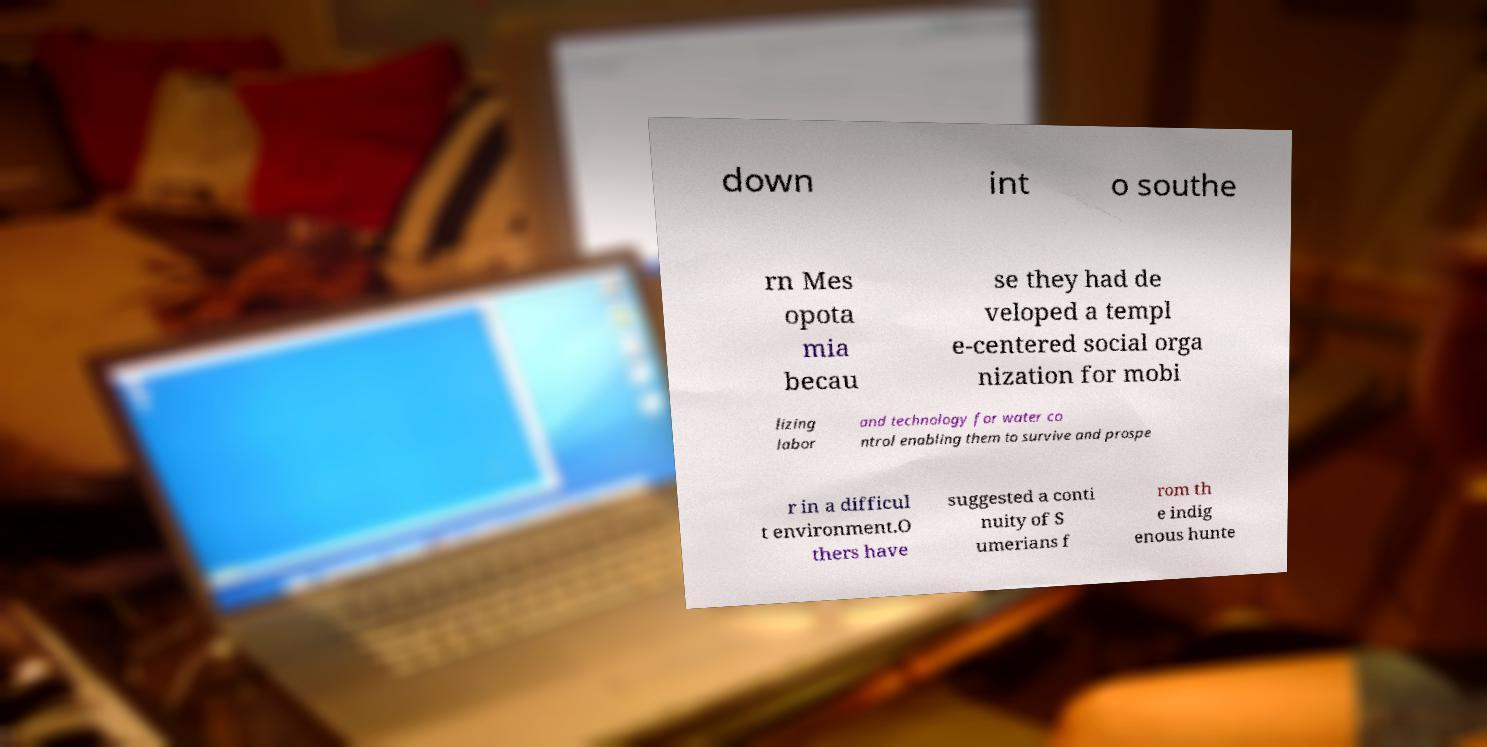Please identify and transcribe the text found in this image. down int o southe rn Mes opota mia becau se they had de veloped a templ e-centered social orga nization for mobi lizing labor and technology for water co ntrol enabling them to survive and prospe r in a difficul t environment.O thers have suggested a conti nuity of S umerians f rom th e indig enous hunte 